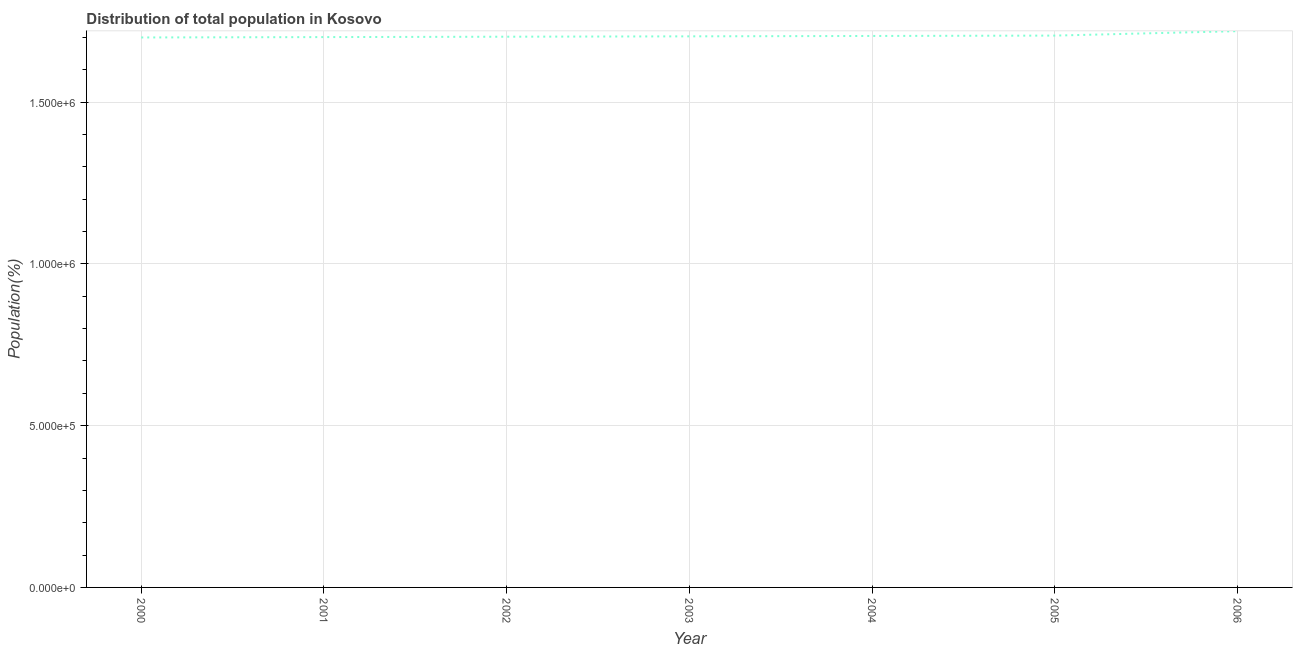What is the population in 2006?
Your answer should be very brief. 1.72e+06. Across all years, what is the maximum population?
Offer a very short reply. 1.72e+06. Across all years, what is the minimum population?
Your answer should be compact. 1.70e+06. What is the sum of the population?
Offer a terse response. 1.19e+07. What is the difference between the population in 2002 and 2006?
Make the answer very short. -1.72e+04. What is the average population per year?
Make the answer very short. 1.71e+06. What is the median population?
Ensure brevity in your answer.  1.70e+06. Do a majority of the years between 2003 and 2005 (inclusive) have population greater than 500000 %?
Offer a very short reply. Yes. What is the ratio of the population in 2000 to that in 2003?
Your response must be concise. 1. What is the difference between the highest and the second highest population?
Offer a terse response. 1.38e+04. Is the sum of the population in 2001 and 2006 greater than the maximum population across all years?
Offer a very short reply. Yes. What is the difference between the highest and the lowest population?
Your response must be concise. 1.95e+04. Does the population monotonically increase over the years?
Provide a succinct answer. Yes. How many lines are there?
Provide a succinct answer. 1. How many years are there in the graph?
Give a very brief answer. 7. Are the values on the major ticks of Y-axis written in scientific E-notation?
Your response must be concise. Yes. What is the title of the graph?
Your answer should be very brief. Distribution of total population in Kosovo . What is the label or title of the X-axis?
Provide a short and direct response. Year. What is the label or title of the Y-axis?
Provide a short and direct response. Population(%). What is the Population(%) of 2000?
Provide a short and direct response. 1.70e+06. What is the Population(%) of 2001?
Your response must be concise. 1.70e+06. What is the Population(%) in 2002?
Your response must be concise. 1.70e+06. What is the Population(%) of 2003?
Give a very brief answer. 1.70e+06. What is the Population(%) of 2004?
Give a very brief answer. 1.70e+06. What is the Population(%) of 2005?
Provide a short and direct response. 1.71e+06. What is the Population(%) in 2006?
Keep it short and to the point. 1.72e+06. What is the difference between the Population(%) in 2000 and 2001?
Your answer should be very brief. -1154. What is the difference between the Population(%) in 2000 and 2002?
Provide a short and direct response. -2310. What is the difference between the Population(%) in 2000 and 2003?
Give a very brief answer. -3466. What is the difference between the Population(%) in 2000 and 2004?
Give a very brief answer. -4622. What is the difference between the Population(%) in 2000 and 2005?
Ensure brevity in your answer.  -5780. What is the difference between the Population(%) in 2000 and 2006?
Give a very brief answer. -1.95e+04. What is the difference between the Population(%) in 2001 and 2002?
Give a very brief answer. -1156. What is the difference between the Population(%) in 2001 and 2003?
Your answer should be very brief. -2312. What is the difference between the Population(%) in 2001 and 2004?
Keep it short and to the point. -3468. What is the difference between the Population(%) in 2001 and 2005?
Your response must be concise. -4626. What is the difference between the Population(%) in 2001 and 2006?
Provide a short and direct response. -1.84e+04. What is the difference between the Population(%) in 2002 and 2003?
Offer a very short reply. -1156. What is the difference between the Population(%) in 2002 and 2004?
Provide a short and direct response. -2312. What is the difference between the Population(%) in 2002 and 2005?
Your response must be concise. -3470. What is the difference between the Population(%) in 2002 and 2006?
Your answer should be very brief. -1.72e+04. What is the difference between the Population(%) in 2003 and 2004?
Provide a short and direct response. -1156. What is the difference between the Population(%) in 2003 and 2005?
Your answer should be very brief. -2314. What is the difference between the Population(%) in 2003 and 2006?
Your response must be concise. -1.61e+04. What is the difference between the Population(%) in 2004 and 2005?
Offer a terse response. -1158. What is the difference between the Population(%) in 2004 and 2006?
Your response must be concise. -1.49e+04. What is the difference between the Population(%) in 2005 and 2006?
Offer a terse response. -1.38e+04. What is the ratio of the Population(%) in 2000 to that in 2001?
Ensure brevity in your answer.  1. What is the ratio of the Population(%) in 2000 to that in 2002?
Provide a short and direct response. 1. What is the ratio of the Population(%) in 2000 to that in 2005?
Offer a terse response. 1. What is the ratio of the Population(%) in 2000 to that in 2006?
Provide a succinct answer. 0.99. What is the ratio of the Population(%) in 2001 to that in 2002?
Your answer should be compact. 1. What is the ratio of the Population(%) in 2001 to that in 2004?
Provide a short and direct response. 1. What is the ratio of the Population(%) in 2001 to that in 2006?
Your answer should be very brief. 0.99. What is the ratio of the Population(%) in 2003 to that in 2004?
Offer a very short reply. 1. What is the ratio of the Population(%) in 2005 to that in 2006?
Make the answer very short. 0.99. 